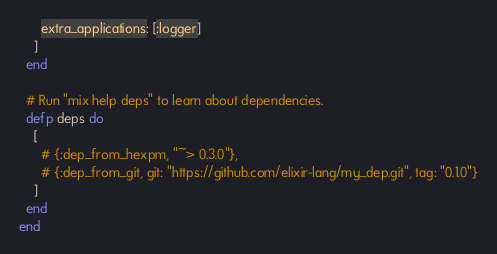<code> <loc_0><loc_0><loc_500><loc_500><_Elixir_>      extra_applications: [:logger]
    ]
  end

  # Run "mix help deps" to learn about dependencies.
  defp deps do
    [
      # {:dep_from_hexpm, "~> 0.3.0"},
      # {:dep_from_git, git: "https://github.com/elixir-lang/my_dep.git", tag: "0.1.0"}
    ]
  end
end
</code> 